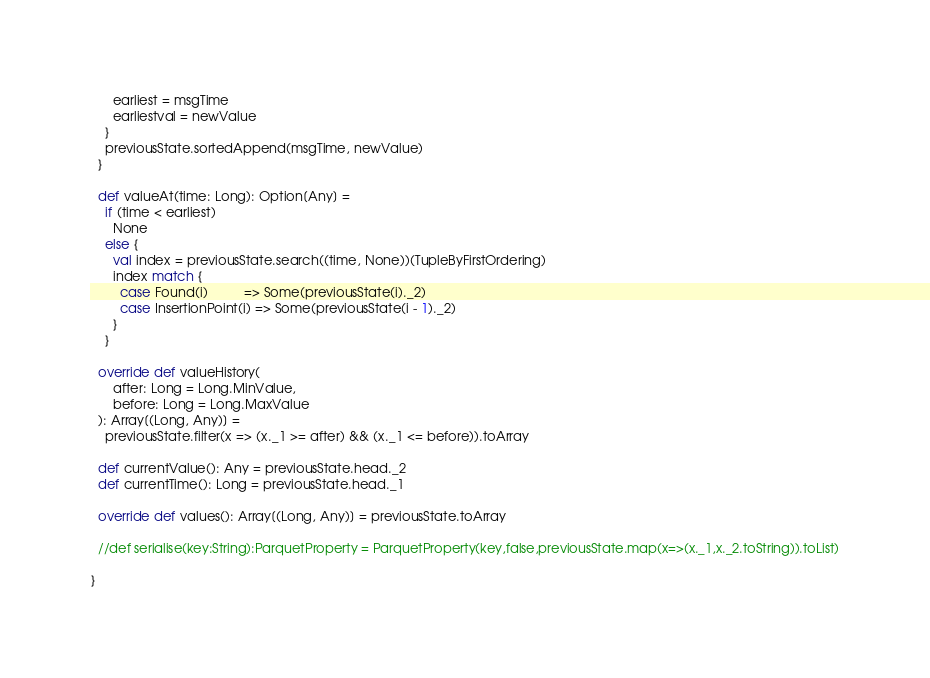<code> <loc_0><loc_0><loc_500><loc_500><_Scala_>      earliest = msgTime
      earliestval = newValue
    }
    previousState.sortedAppend(msgTime, newValue)
  }

  def valueAt(time: Long): Option[Any] =
    if (time < earliest)
      None
    else {
      val index = previousState.search((time, None))(TupleByFirstOrdering)
      index match {
        case Found(i)          => Some(previousState(i)._2)
        case InsertionPoint(i) => Some(previousState(i - 1)._2)
      }
    }

  override def valueHistory(
      after: Long = Long.MinValue,
      before: Long = Long.MaxValue
  ): Array[(Long, Any)] =
    previousState.filter(x => (x._1 >= after) && (x._1 <= before)).toArray

  def currentValue(): Any = previousState.head._2
  def currentTime(): Long = previousState.head._1

  override def values(): Array[(Long, Any)] = previousState.toArray

  //def serialise(key:String):ParquetProperty = ParquetProperty(key,false,previousState.map(x=>(x._1,x._2.toString)).toList)

}
</code> 